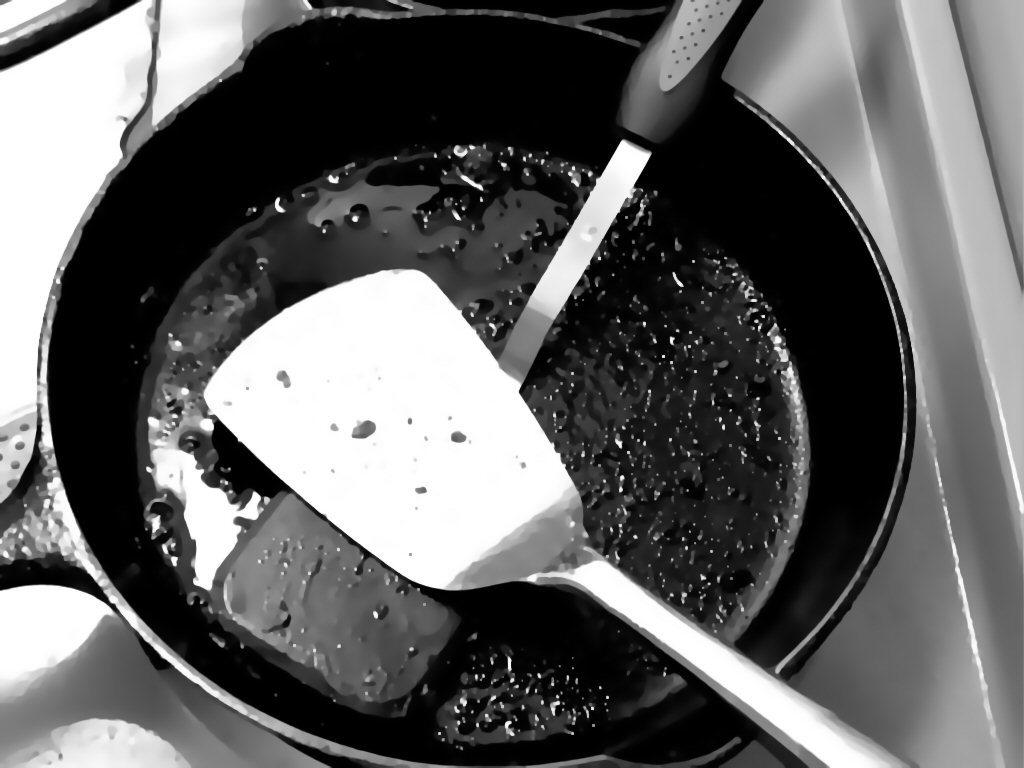How many spatulas are visible in the image? There are two spatulas in the image. What are the spatulas placed on? The spatulas are on a black pan. Where is the black pan located? The black pan is on a stove. What type of request can be heard coming from the edge of the stove in the image? There is no request or sound coming from the edge of the stove in the image. 